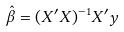Convert formula to latex. <formula><loc_0><loc_0><loc_500><loc_500>\hat { \beta } = ( X ^ { \prime } X ) ^ { - 1 } X ^ { \prime } y</formula> 